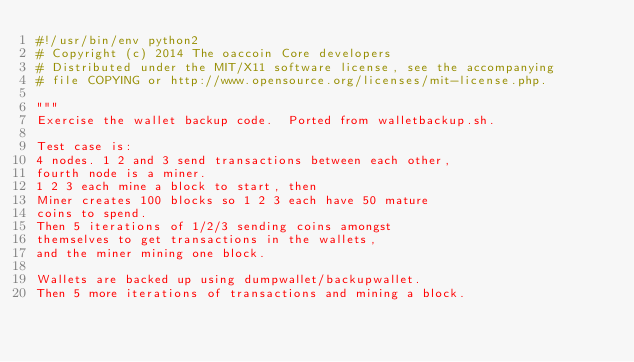Convert code to text. <code><loc_0><loc_0><loc_500><loc_500><_Python_>#!/usr/bin/env python2
# Copyright (c) 2014 The oaccoin Core developers
# Distributed under the MIT/X11 software license, see the accompanying
# file COPYING or http://www.opensource.org/licenses/mit-license.php.

"""
Exercise the wallet backup code.  Ported from walletbackup.sh.

Test case is:
4 nodes. 1 2 and 3 send transactions between each other,
fourth node is a miner.
1 2 3 each mine a block to start, then
Miner creates 100 blocks so 1 2 3 each have 50 mature
coins to spend.
Then 5 iterations of 1/2/3 sending coins amongst
themselves to get transactions in the wallets,
and the miner mining one block.

Wallets are backed up using dumpwallet/backupwallet.
Then 5 more iterations of transactions and mining a block.
</code> 